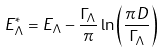<formula> <loc_0><loc_0><loc_500><loc_500>E _ { \Lambda } ^ { * } = E _ { \Lambda } - \frac { \Gamma _ { \Lambda } } { \pi } \ln \left ( \frac { \pi D } { \Gamma _ { \Lambda } } \right )</formula> 